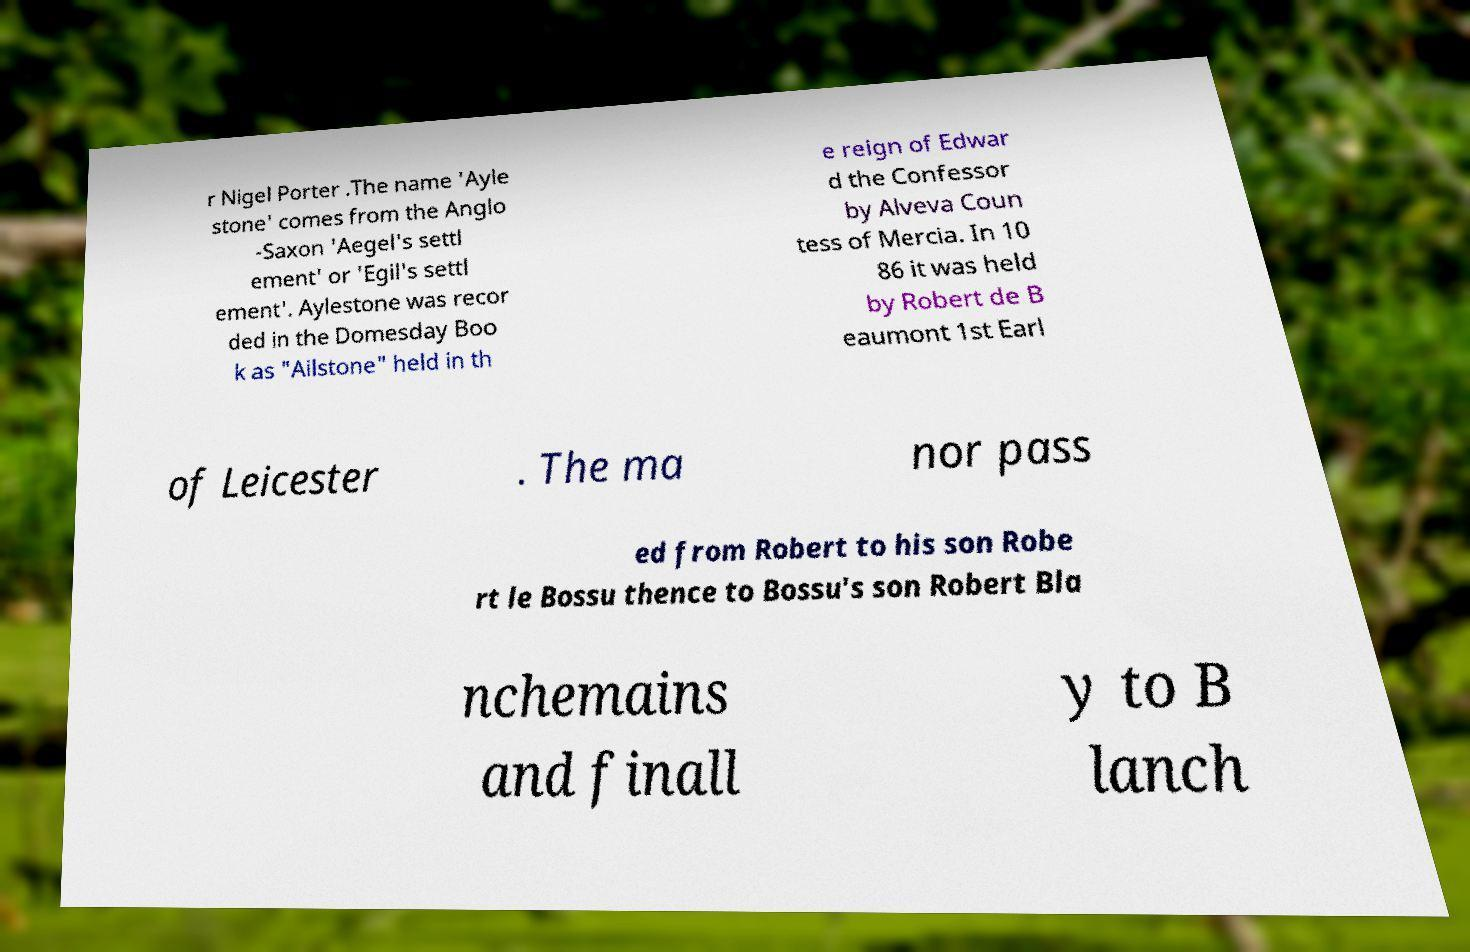Could you assist in decoding the text presented in this image and type it out clearly? r Nigel Porter .The name 'Ayle stone' comes from the Anglo -Saxon 'Aegel's settl ement' or 'Egil's settl ement'. Aylestone was recor ded in the Domesday Boo k as "Ailstone" held in th e reign of Edwar d the Confessor by Alveva Coun tess of Mercia. In 10 86 it was held by Robert de B eaumont 1st Earl of Leicester . The ma nor pass ed from Robert to his son Robe rt le Bossu thence to Bossu's son Robert Bla nchemains and finall y to B lanch 